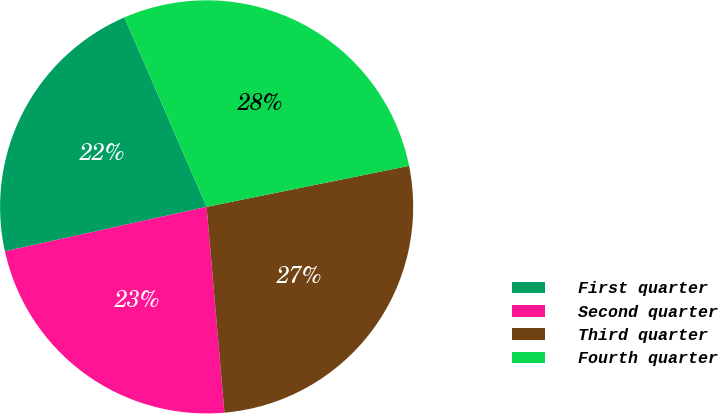<chart> <loc_0><loc_0><loc_500><loc_500><pie_chart><fcel>First quarter<fcel>Second quarter<fcel>Third quarter<fcel>Fourth quarter<nl><fcel>21.94%<fcel>22.92%<fcel>26.81%<fcel>28.33%<nl></chart> 